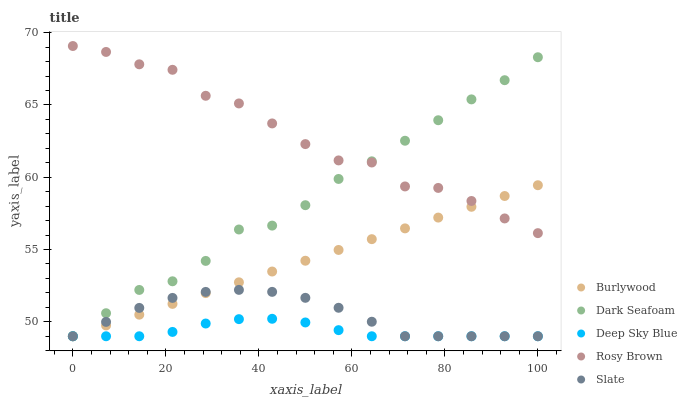Does Deep Sky Blue have the minimum area under the curve?
Answer yes or no. Yes. Does Rosy Brown have the maximum area under the curve?
Answer yes or no. Yes. Does Dark Seafoam have the minimum area under the curve?
Answer yes or no. No. Does Dark Seafoam have the maximum area under the curve?
Answer yes or no. No. Is Burlywood the smoothest?
Answer yes or no. Yes. Is Rosy Brown the roughest?
Answer yes or no. Yes. Is Dark Seafoam the smoothest?
Answer yes or no. No. Is Dark Seafoam the roughest?
Answer yes or no. No. Does Burlywood have the lowest value?
Answer yes or no. Yes. Does Rosy Brown have the lowest value?
Answer yes or no. No. Does Rosy Brown have the highest value?
Answer yes or no. Yes. Does Dark Seafoam have the highest value?
Answer yes or no. No. Is Slate less than Rosy Brown?
Answer yes or no. Yes. Is Rosy Brown greater than Slate?
Answer yes or no. Yes. Does Slate intersect Deep Sky Blue?
Answer yes or no. Yes. Is Slate less than Deep Sky Blue?
Answer yes or no. No. Is Slate greater than Deep Sky Blue?
Answer yes or no. No. Does Slate intersect Rosy Brown?
Answer yes or no. No. 